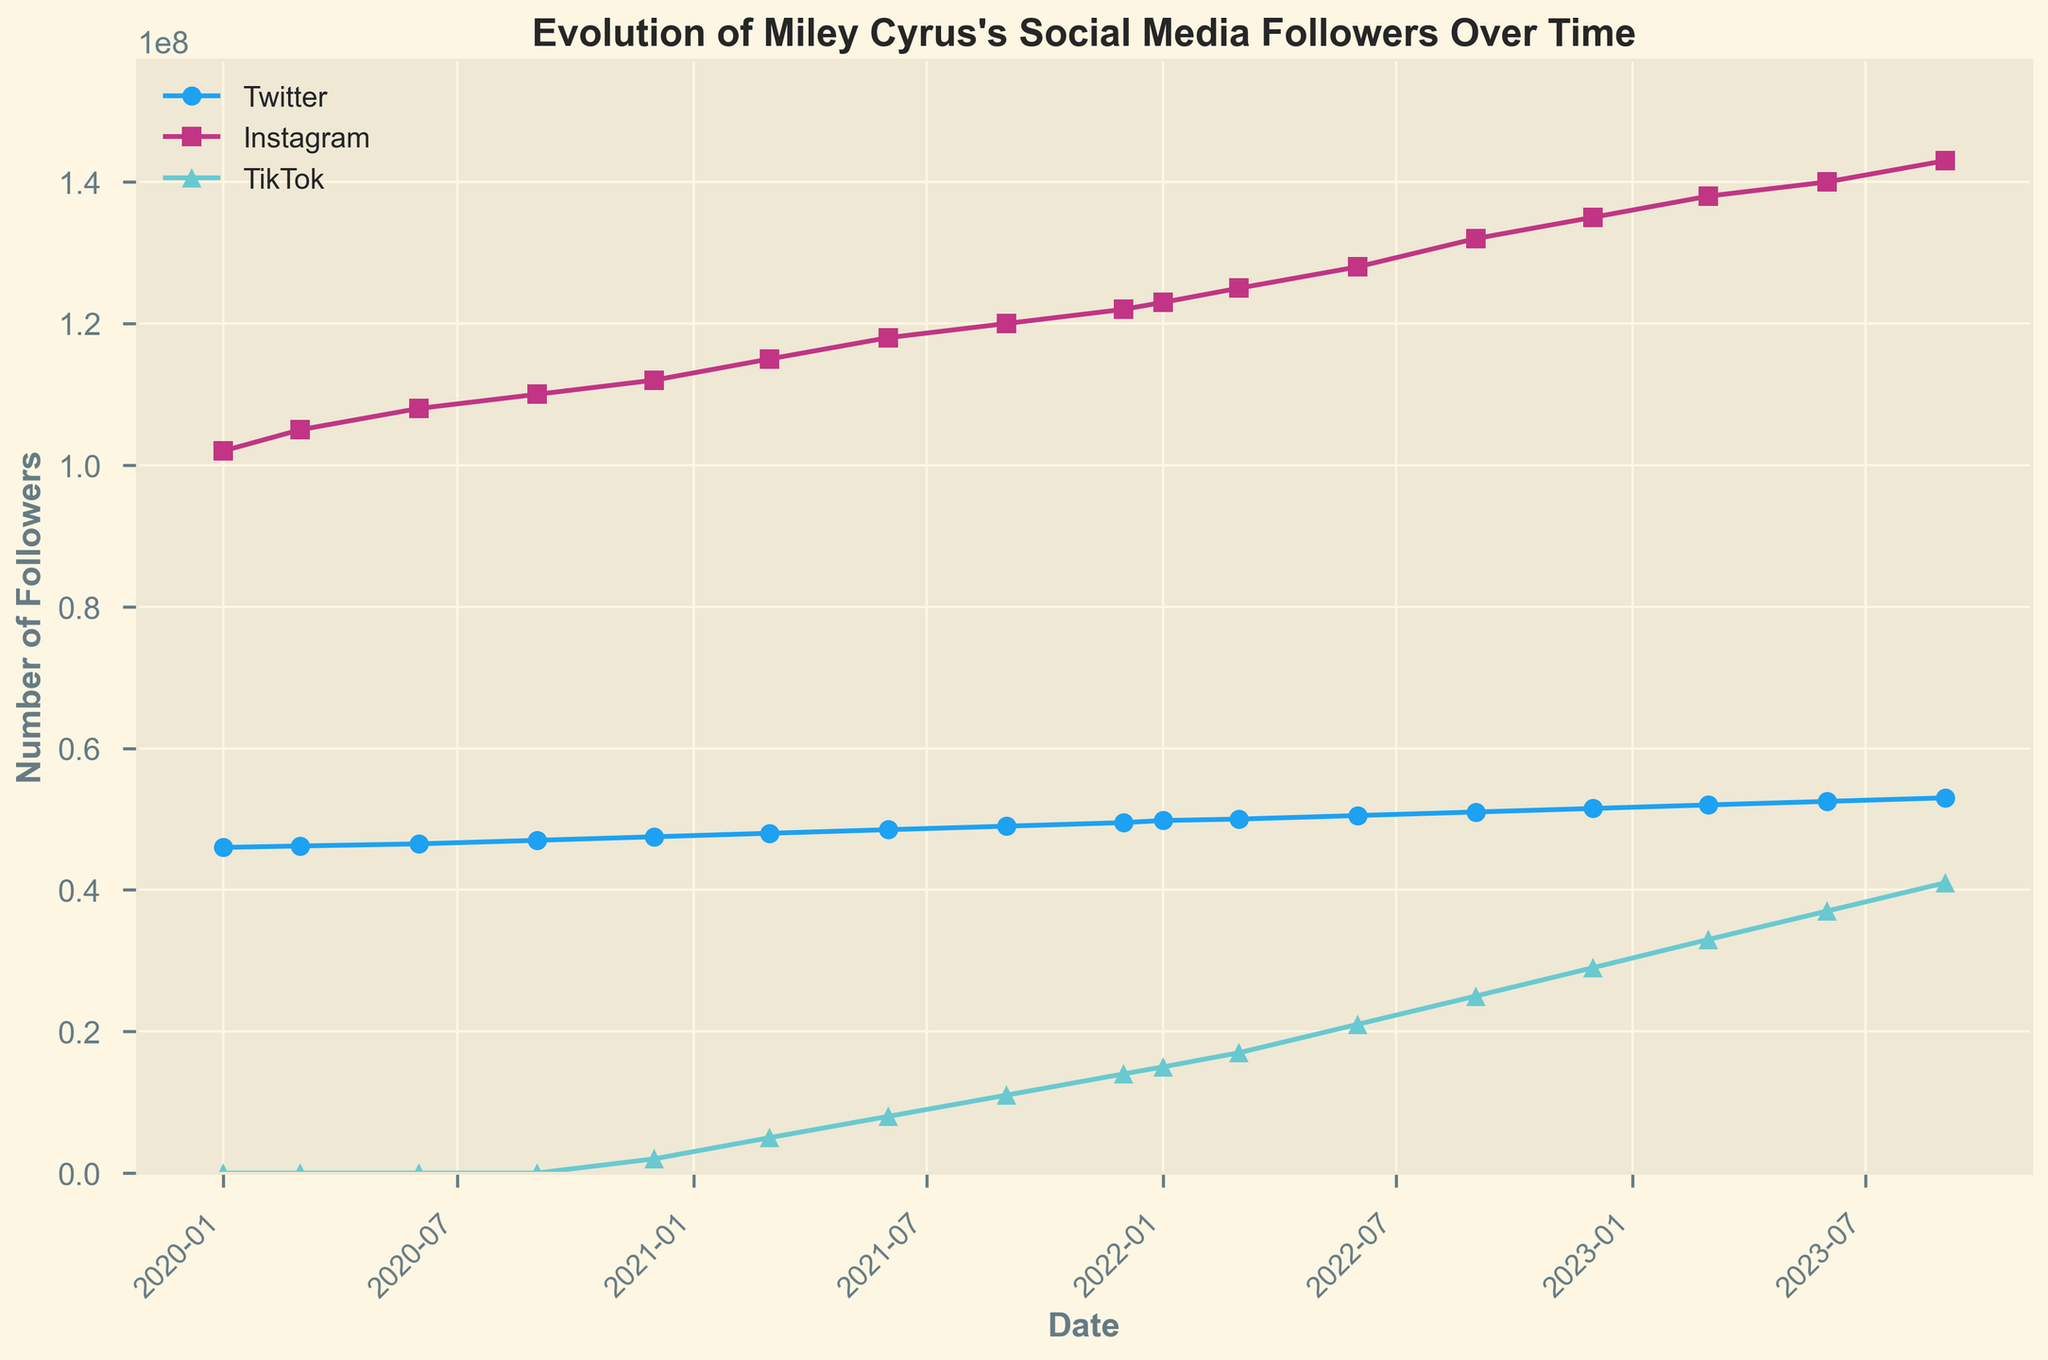What's the general trend of Miley Cyrus's Instagram followers over the time period shown? The general trend is upward. The number of followers increases steadily from around 102 million in January 2020 to 143 million in September 2023, indicating a consistent growth in her Instagram followers.
Answer: Upward When did Miley Cyrus’s TikTok followers start showing up in the data? TikTok followers data starts from December 2020, where the count starts from 2 million and increases rapidly thereafter.
Answer: December 2020 Which platform had the highest number of followers at any point in time? Instagram consistently had the highest number of followers throughout the given time period. In September 2023, the highest count shown is for Instagram with 143 million followers.
Answer: Instagram Which quarter showed the highest increase in TikTok followers? The highest increase is between September 2022 and December 2022, where followers increased from 25 million to 29 million.
Answer: Q4 2022 By how much did Miley's Twitter followers increase from January 2020 to September 2023? Miley’s Twitter followers increased from 46 million in January 2020 to 53 million in September 2023. The difference is 53 million - 46 million = 7 million.
Answer: 7 million What is the difference in the number of Instagram followers between the start and end of 2022? At the start of 2022, she had 123 million followers, and at the end, she had 135 million. The difference is 135 million - 123 million = 12 million.
Answer: 12 million Describe the trend for Miley Cyrus's followers on TikTok compared to Twitter. TikTok followers show a rapid increase starting from nothing in January 2020 to 41 million in September 2023. Twitter followers show a slower, steadier increase from 46 million to 53 million in the same period.
Answer: TikTok increased rapidly; Twitter increased steadily What was the highest number of TikTok followers Miley Cyrus had by the end of the recorded period? By September 2023, Miley Cyrus had 41 million followers on TikTok.
Answer: 41 million What visual attribute do you notice between the different platform lines in the plot? Each platform is represented by a different color and marker: Twitter in blue with circles, Instagram in magenta with squares, and TikTok in cyan with triangles.
Answer: Different colors and markers Which period shows the most substantial combined increase in followers across all platforms? The substantial combined increase occurred between September 2022 and September 2023, driven mainly by rapid TikTok follower growth and steady Instagram increases.
Answer: Sep 2022 to Sep 2023 